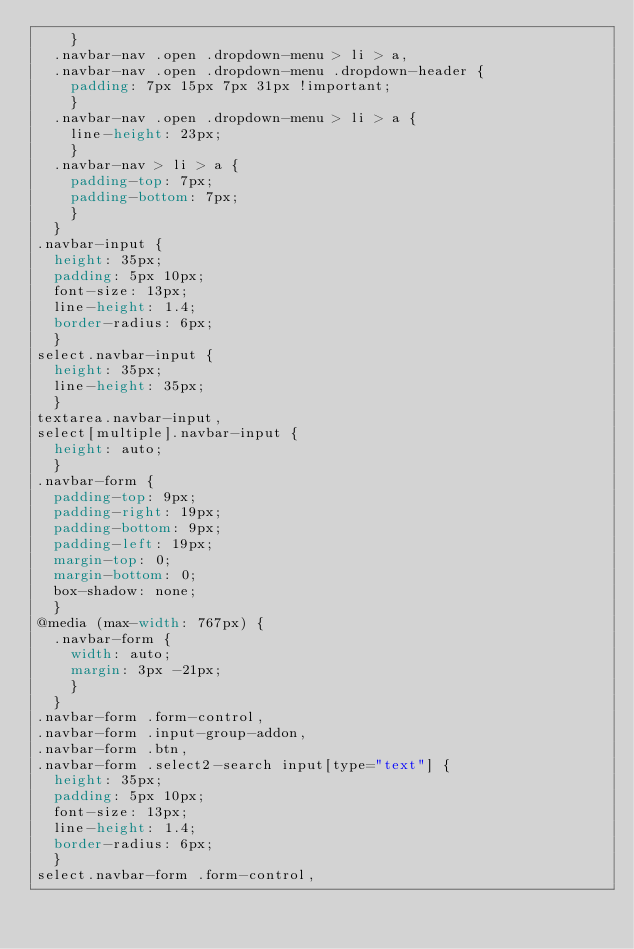<code> <loc_0><loc_0><loc_500><loc_500><_CSS_>    }
  .navbar-nav .open .dropdown-menu > li > a,
  .navbar-nav .open .dropdown-menu .dropdown-header {
    padding: 7px 15px 7px 31px !important;
    }
  .navbar-nav .open .dropdown-menu > li > a {
    line-height: 23px;
    }
  .navbar-nav > li > a {
    padding-top: 7px;
    padding-bottom: 7px;
    }
  }
.navbar-input {
  height: 35px;
  padding: 5px 10px;
  font-size: 13px;
  line-height: 1.4;
  border-radius: 6px;
  }
select.navbar-input {
  height: 35px;
  line-height: 35px;
  }
textarea.navbar-input,
select[multiple].navbar-input {
  height: auto;
  }
.navbar-form {
  padding-top: 9px;
  padding-right: 19px;
  padding-bottom: 9px;
  padding-left: 19px;
  margin-top: 0;
  margin-bottom: 0;
  box-shadow: none;
  }
@media (max-width: 767px) {
  .navbar-form {
    width: auto;
    margin: 3px -21px;
    }
  }
.navbar-form .form-control,
.navbar-form .input-group-addon,
.navbar-form .btn,
.navbar-form .select2-search input[type="text"] {
  height: 35px;
  padding: 5px 10px;
  font-size: 13px;
  line-height: 1.4;
  border-radius: 6px;
  }
select.navbar-form .form-control,</code> 